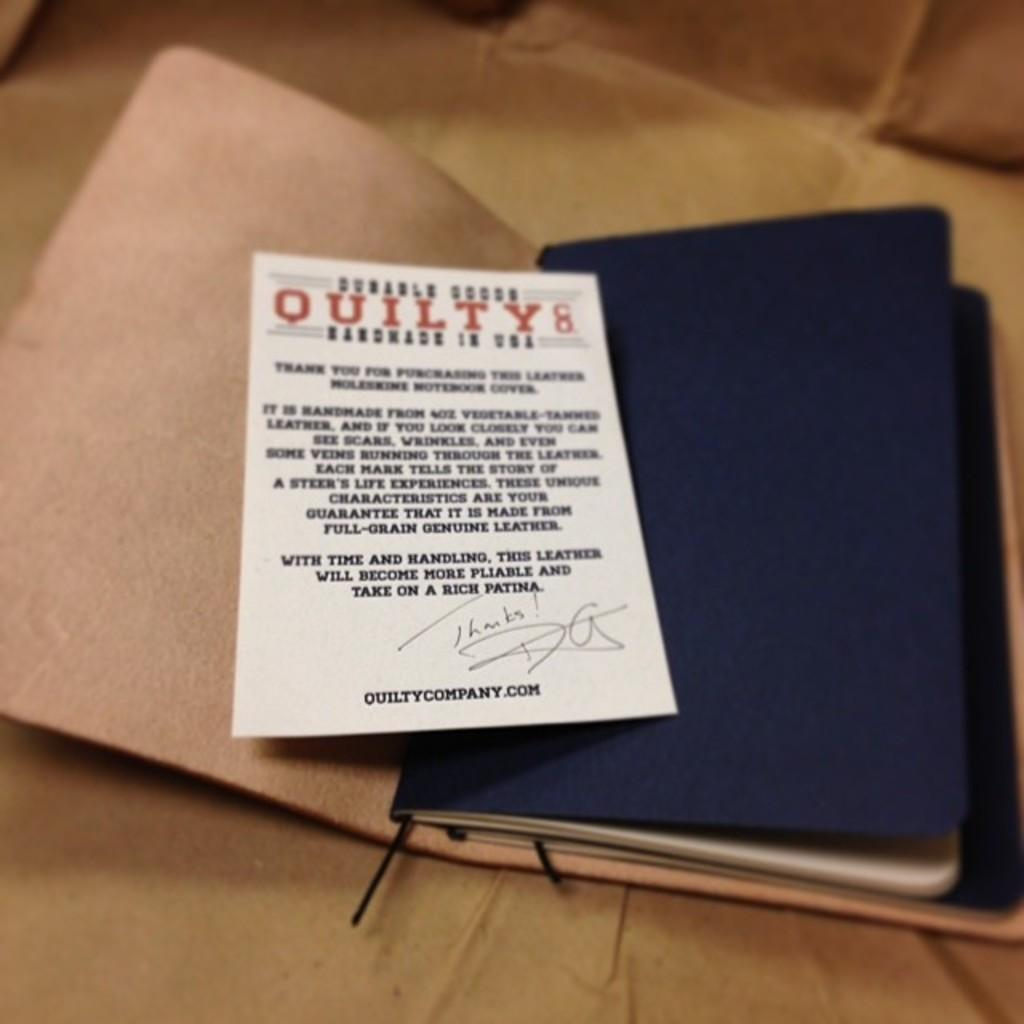<image>
Describe the image concisely. a notebook with a note about Quilty inside it 